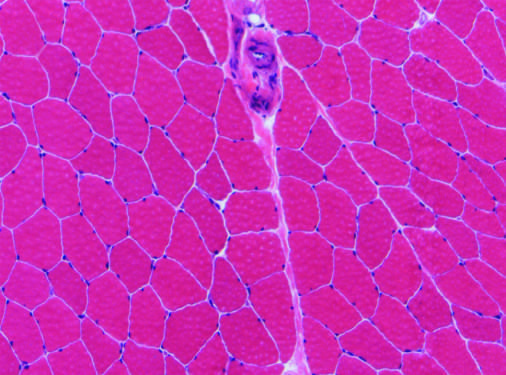s remission of demyelinating disease present?
Answer the question using a single word or phrase. No 